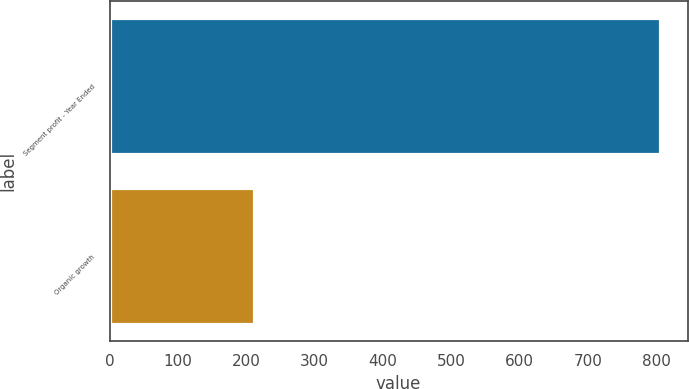Convert chart. <chart><loc_0><loc_0><loc_500><loc_500><bar_chart><fcel>Segment profit - Year Ended<fcel>Organic growth<nl><fcel>805.8<fcel>211.8<nl></chart> 